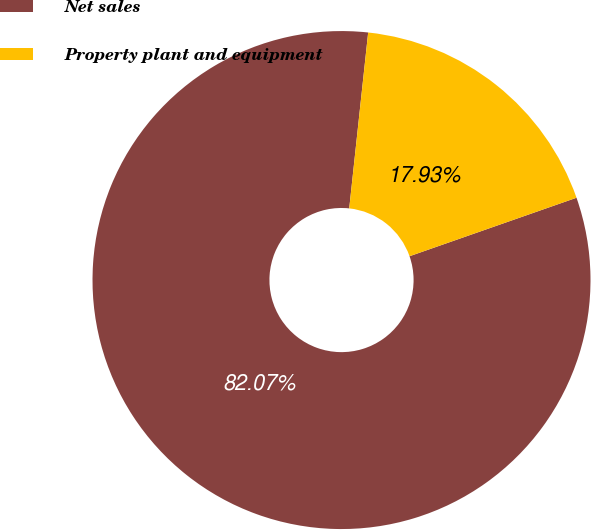Convert chart to OTSL. <chart><loc_0><loc_0><loc_500><loc_500><pie_chart><fcel>Net sales<fcel>Property plant and equipment<nl><fcel>82.07%<fcel>17.93%<nl></chart> 